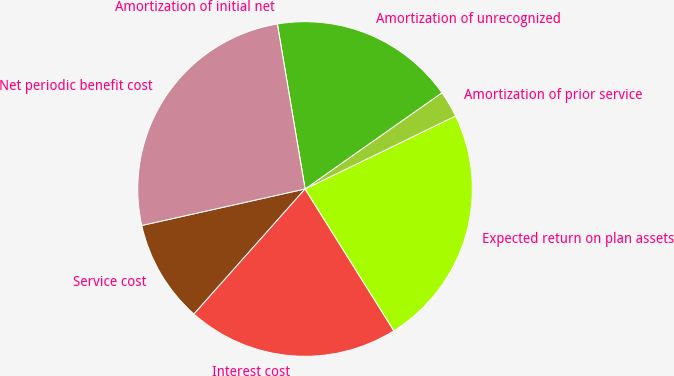<chart> <loc_0><loc_0><loc_500><loc_500><pie_chart><fcel>Service cost<fcel>Interest cost<fcel>Expected return on plan assets<fcel>Amortization of prior service<fcel>Amortization of unrecognized<fcel>Amortization of initial net<fcel>Net periodic benefit cost<nl><fcel>9.94%<fcel>20.47%<fcel>23.28%<fcel>2.57%<fcel>17.9%<fcel>0.0%<fcel>25.85%<nl></chart> 